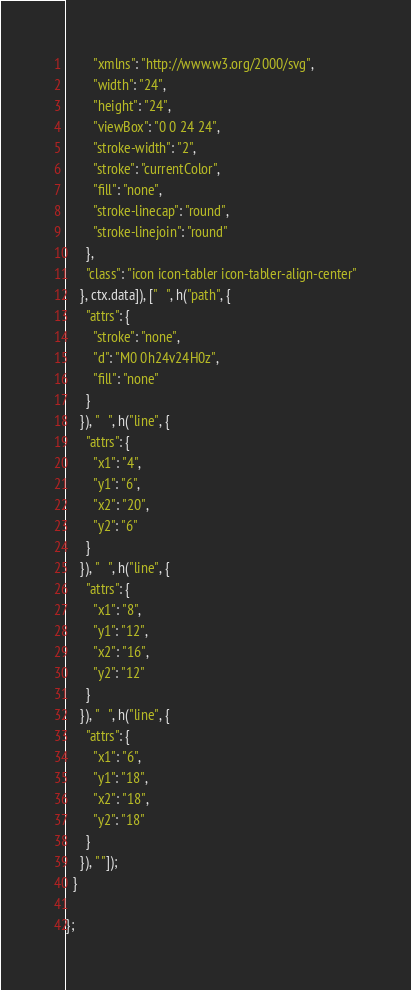<code> <loc_0><loc_0><loc_500><loc_500><_JavaScript_>        "xmlns": "http://www.w3.org/2000/svg",
        "width": "24",
        "height": "24",
        "viewBox": "0 0 24 24",
        "stroke-width": "2",
        "stroke": "currentColor",
        "fill": "none",
        "stroke-linecap": "round",
        "stroke-linejoin": "round"
      },
      "class": "icon icon-tabler icon-tabler-align-center"
    }, ctx.data]), ["   ", h("path", {
      "attrs": {
        "stroke": "none",
        "d": "M0 0h24v24H0z",
        "fill": "none"
      }
    }), "   ", h("line", {
      "attrs": {
        "x1": "4",
        "y1": "6",
        "x2": "20",
        "y2": "6"
      }
    }), "   ", h("line", {
      "attrs": {
        "x1": "8",
        "y1": "12",
        "x2": "16",
        "y2": "12"
      }
    }), "   ", h("line", {
      "attrs": {
        "x1": "6",
        "y1": "18",
        "x2": "18",
        "y2": "18"
      }
    }), " "]);
  }

};</code> 